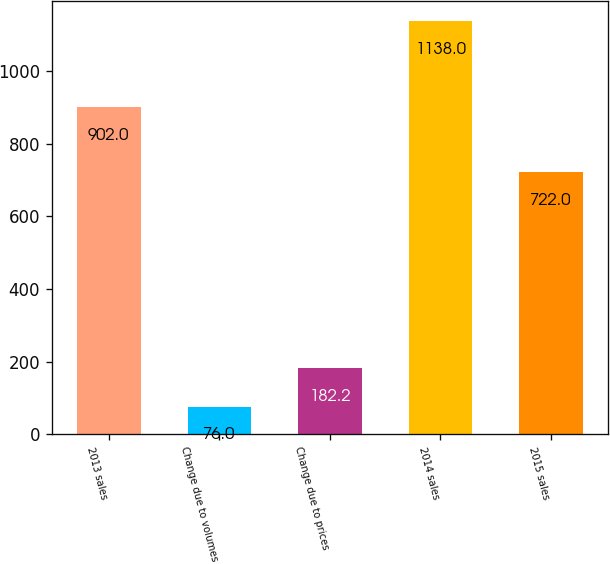Convert chart to OTSL. <chart><loc_0><loc_0><loc_500><loc_500><bar_chart><fcel>2013 sales<fcel>Change due to volumes<fcel>Change due to prices<fcel>2014 sales<fcel>2015 sales<nl><fcel>902<fcel>76<fcel>182.2<fcel>1138<fcel>722<nl></chart> 